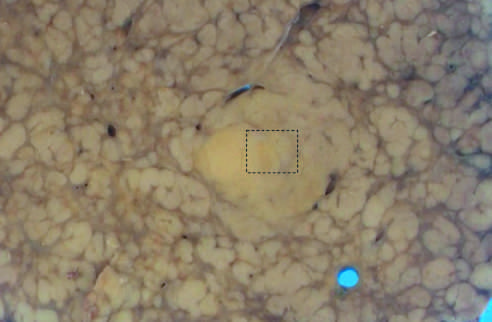does escherichia suggest an evolving cancer?
Answer the question using a single word or phrase. No 